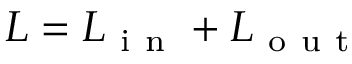<formula> <loc_0><loc_0><loc_500><loc_500>L = L _ { i n } + L _ { o u t }</formula> 